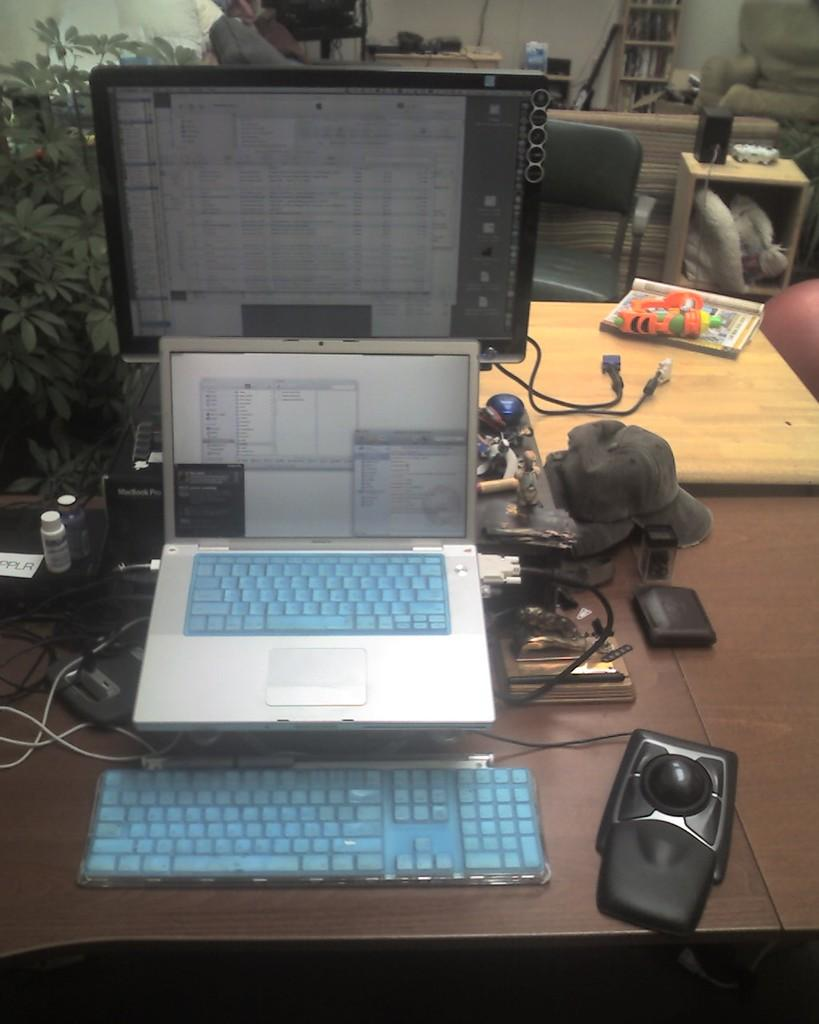What electronic devices are on the table in the image? There is a monitor and a laptop on the table in the image. What other items can be seen on the table? There are bottles, wires, a cap, a purse, a toy, and a book on the table. What can be seen in the background of the image? There are trees, chairs, a rack, a sofa, and a speaker in the background. How does the image show an increase in the number of dad's losses? The image does not show any information about dad or losses; it features a table with various objects and a background with furniture and a speaker. 